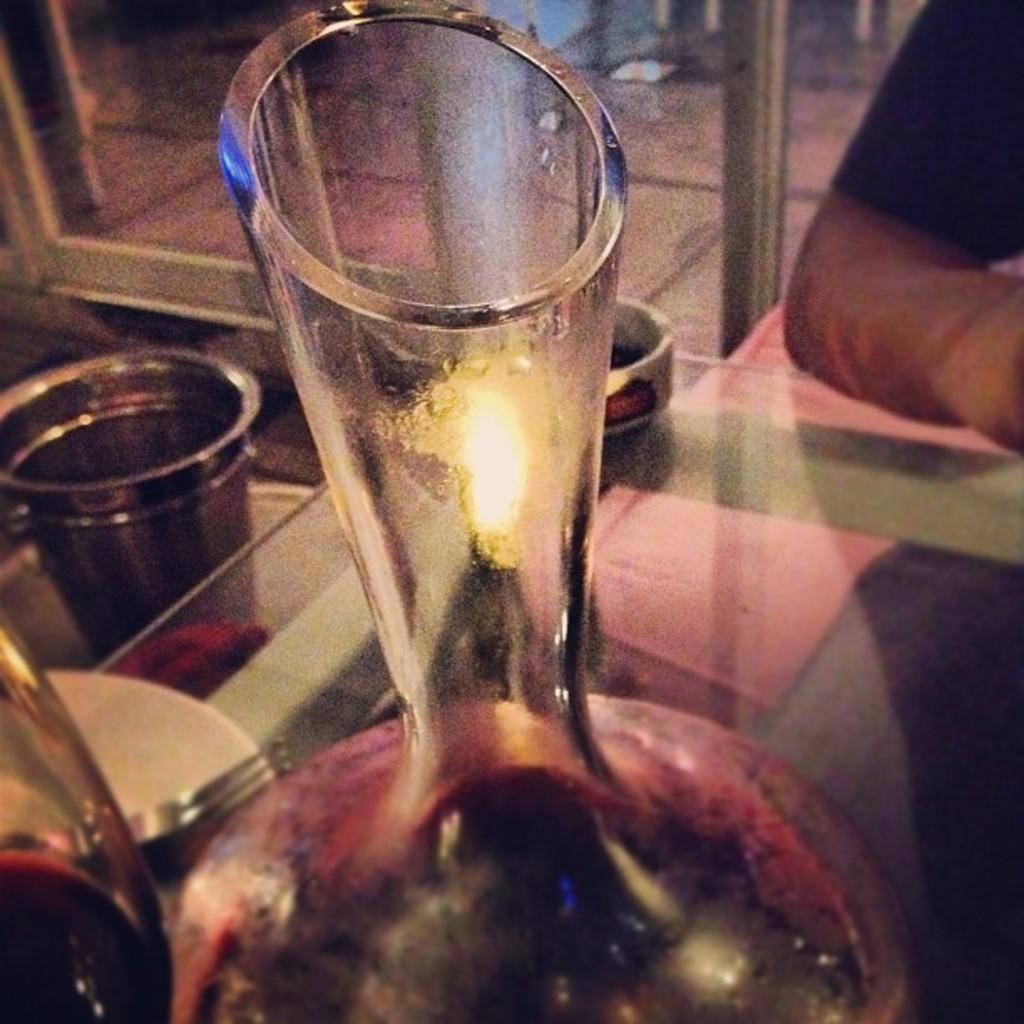Describe this image in one or two sentences. In this picture we can see some glasses are placed on the glass table and we can see a person hand. 